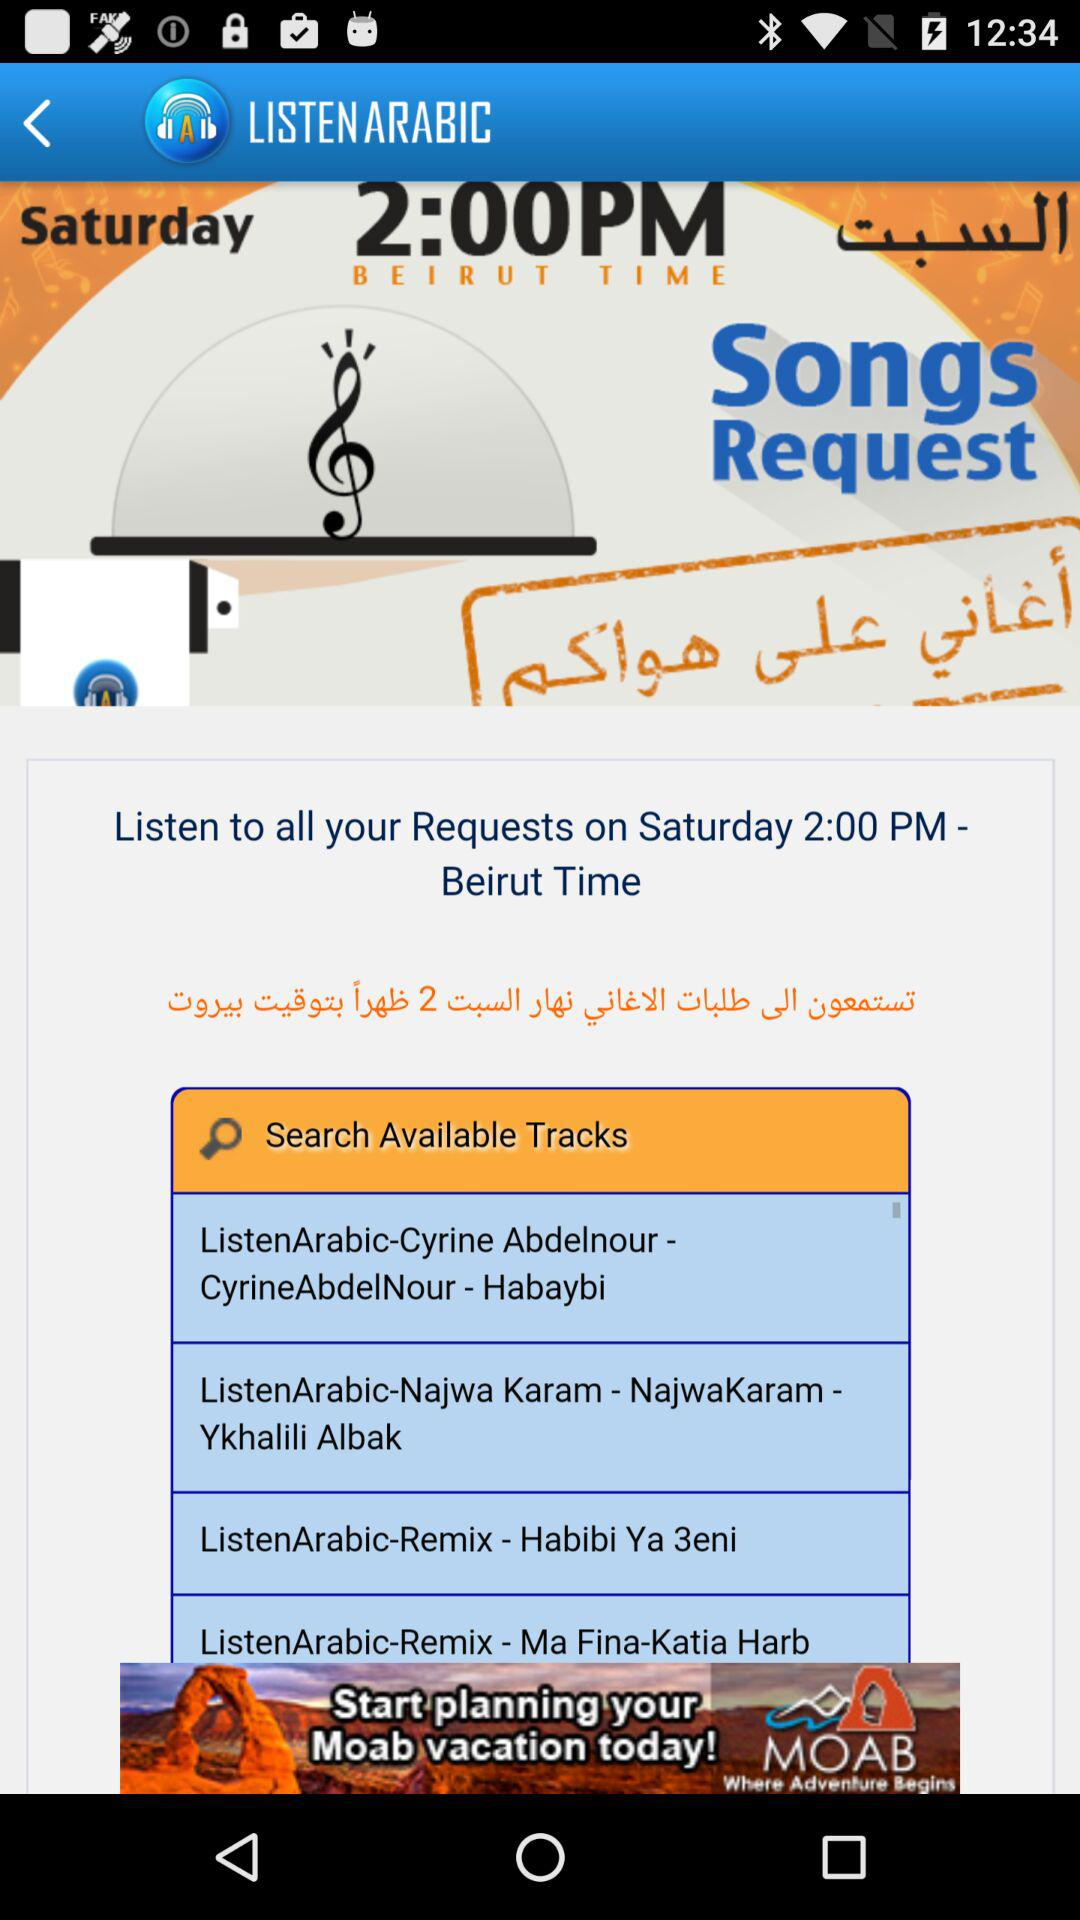What Beirut time is requested to listen to all requests? The requested Beirut time is 2:00 p.m. 